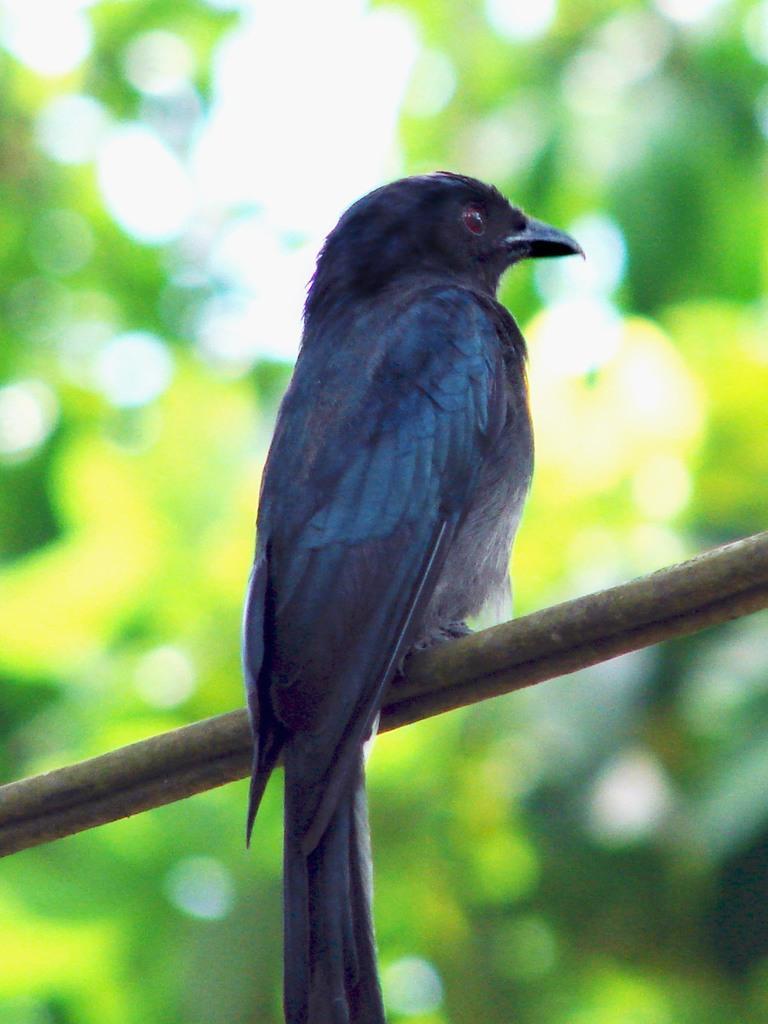In one or two sentences, can you explain what this image depicts? In this picture we can see a bird sitting on a wooden stick. Background is blurry. 